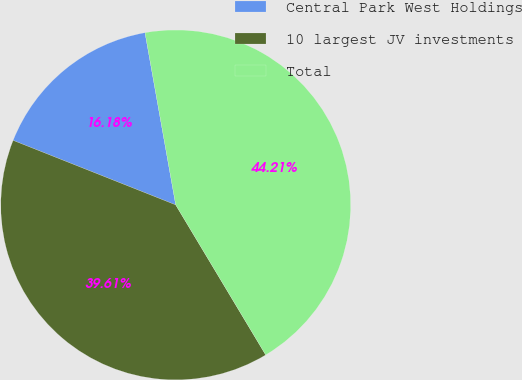Convert chart. <chart><loc_0><loc_0><loc_500><loc_500><pie_chart><fcel>Central Park West Holdings<fcel>10 largest JV investments<fcel>Total<nl><fcel>16.18%<fcel>39.61%<fcel>44.21%<nl></chart> 